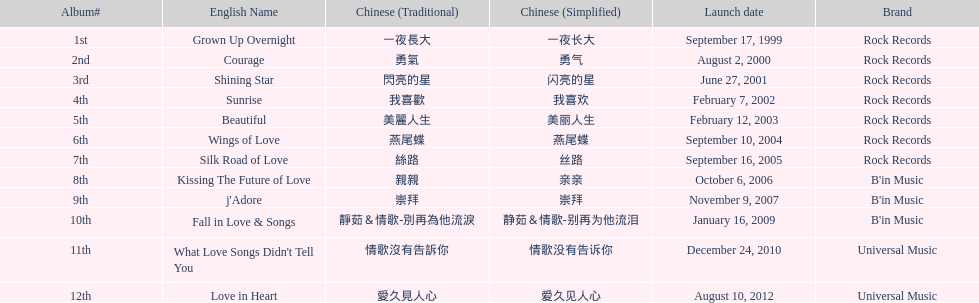Which song is listed first in the table? Grown Up Overnight. 